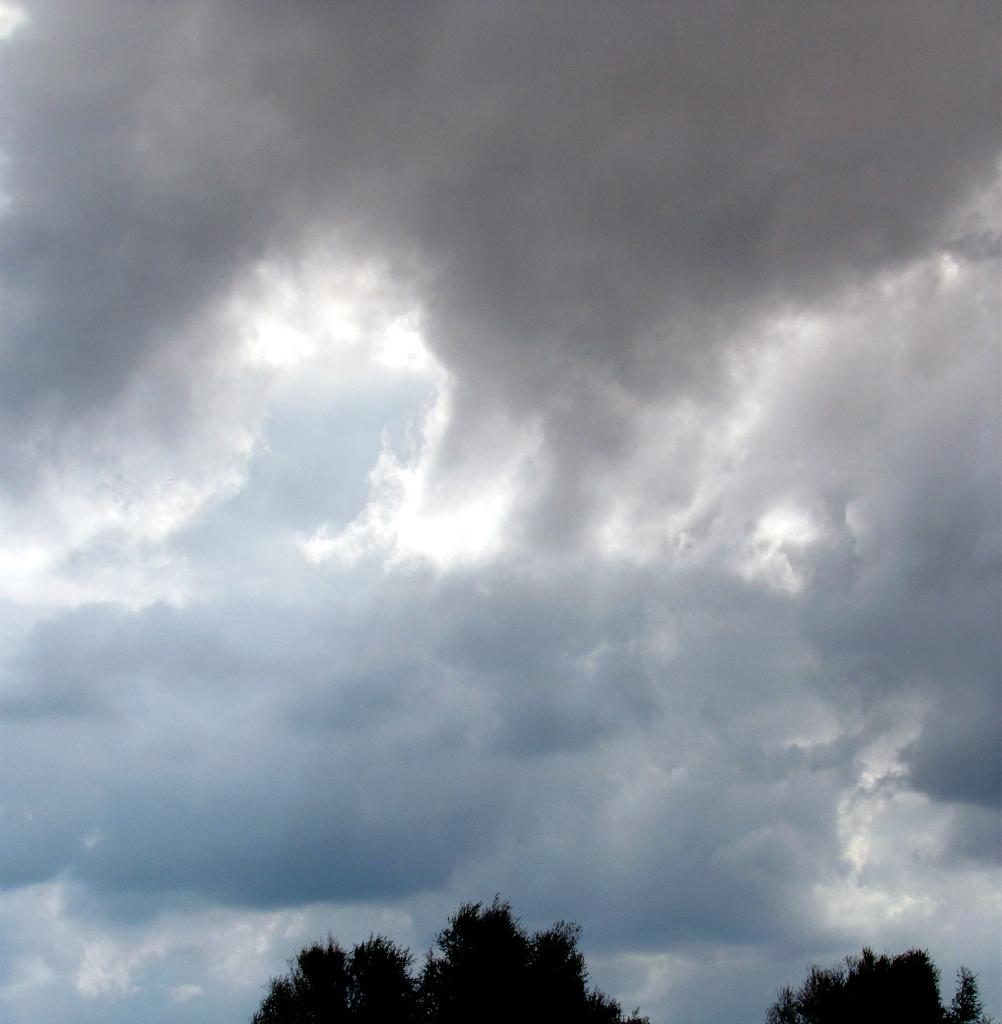What type of vegetation is at the bottom of the picture? There are trees at the bottom of the picture. What is visible in the middle of the image? The sky is visible in the middle of the image. How would you describe the sky in the image? The sky appears to be cloudy. What type of fruit can be seen hanging from the trees at the bottom of the image? There is no fruit visible in the image; only trees are present at the bottom of the picture. Is there a fire burning in the middle of the image? No, there is no fire present in the image; only the sky is visible in the middle of the picture. 